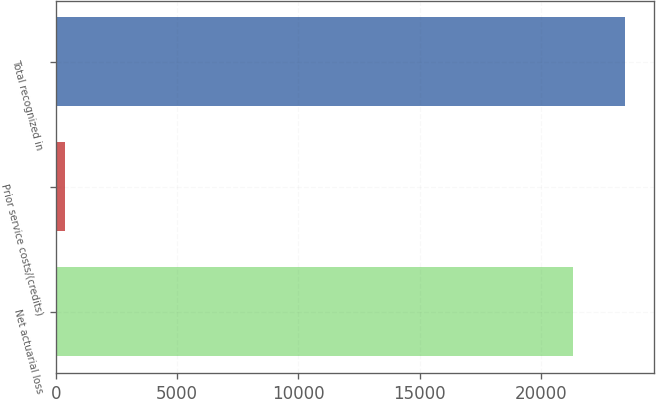<chart> <loc_0><loc_0><loc_500><loc_500><bar_chart><fcel>Net actuarial loss<fcel>Prior service costs/(credits)<fcel>Total recognized in<nl><fcel>21321<fcel>385<fcel>23453.1<nl></chart> 